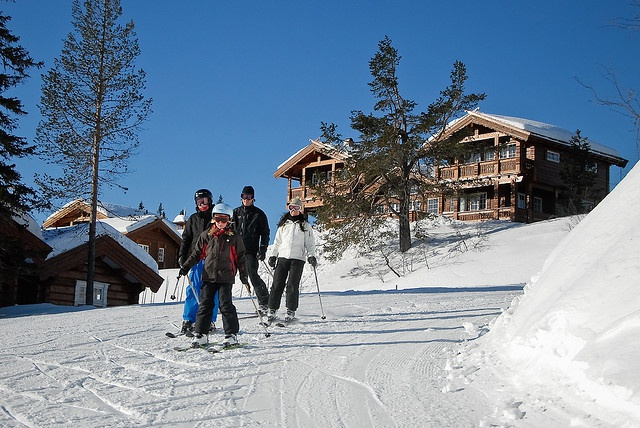Describe the objects in this image and their specific colors. I can see people in blue, black, gray, maroon, and darkgray tones, people in blue, black, darkgray, lightgray, and gray tones, people in blue, black, gray, lightgray, and darkgray tones, people in blue, black, navy, and gray tones, and skis in blue, gray, darkgray, lightgray, and black tones in this image. 